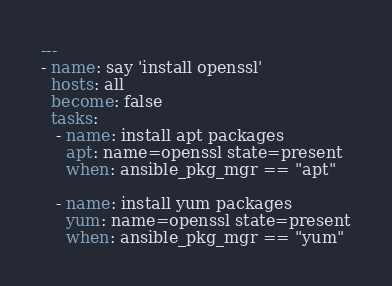<code> <loc_0><loc_0><loc_500><loc_500><_YAML_>---
- name: say 'install openssl'
  hosts: all
  become: false
  tasks:
   - name: install apt packages
     apt: name=openssl state=present
     when: ansible_pkg_mgr == "apt"

   - name: install yum packages
     yum: name=openssl state=present
     when: ansible_pkg_mgr == "yum"
</code> 